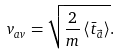<formula> <loc_0><loc_0><loc_500><loc_500>v _ { a v } = \sqrt { \frac { 2 } { m } \left \langle \bar { t } _ { \vec { a } } \right \rangle } .</formula> 